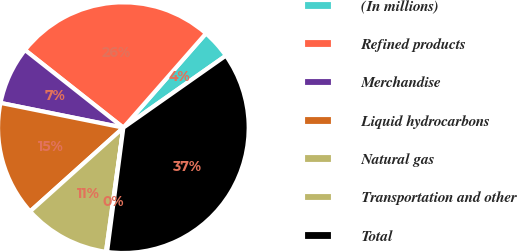Convert chart. <chart><loc_0><loc_0><loc_500><loc_500><pie_chart><fcel>(In millions)<fcel>Refined products<fcel>Merchandise<fcel>Liquid hydrocarbons<fcel>Natural gas<fcel>Transportation and other<fcel>Total<nl><fcel>3.8%<fcel>25.82%<fcel>7.47%<fcel>14.81%<fcel>11.14%<fcel>0.14%<fcel>36.82%<nl></chart> 